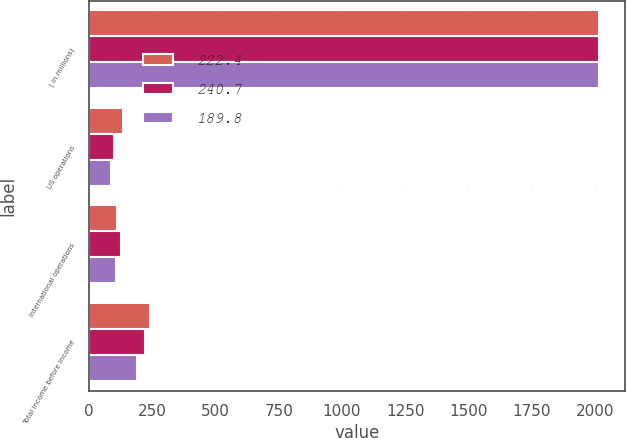Convert chart. <chart><loc_0><loc_0><loc_500><loc_500><stacked_bar_chart><ecel><fcel>( in millions)<fcel>US operations<fcel>International operations<fcel>Total income before income<nl><fcel>222.4<fcel>2018<fcel>132.9<fcel>107.8<fcel>240.7<nl><fcel>240.7<fcel>2017<fcel>96.5<fcel>125.9<fcel>222.4<nl><fcel>189.8<fcel>2016<fcel>84.5<fcel>105.3<fcel>189.8<nl></chart> 